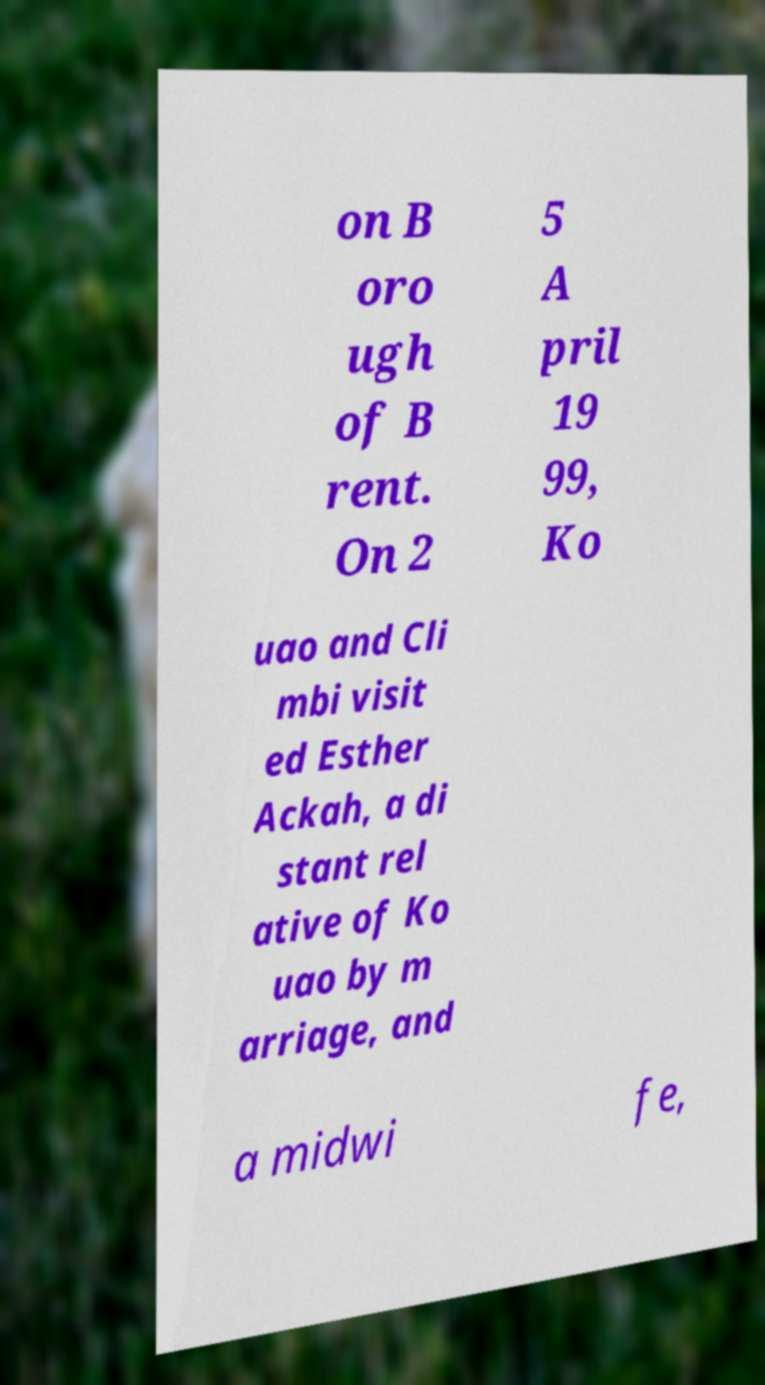For documentation purposes, I need the text within this image transcribed. Could you provide that? on B oro ugh of B rent. On 2 5 A pril 19 99, Ko uao and Cli mbi visit ed Esther Ackah, a di stant rel ative of Ko uao by m arriage, and a midwi fe, 